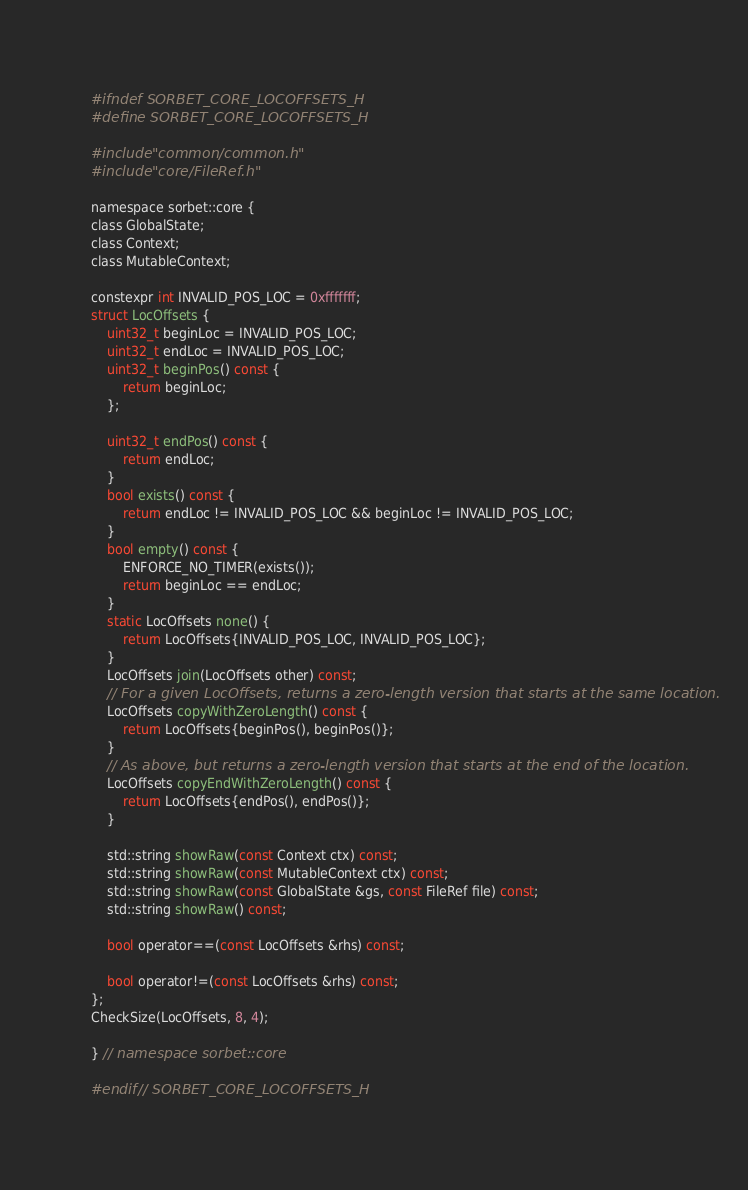<code> <loc_0><loc_0><loc_500><loc_500><_C_>#ifndef SORBET_CORE_LOCOFFSETS_H
#define SORBET_CORE_LOCOFFSETS_H

#include "common/common.h"
#include "core/FileRef.h"

namespace sorbet::core {
class GlobalState;
class Context;
class MutableContext;

constexpr int INVALID_POS_LOC = 0xfffffff;
struct LocOffsets {
    uint32_t beginLoc = INVALID_POS_LOC;
    uint32_t endLoc = INVALID_POS_LOC;
    uint32_t beginPos() const {
        return beginLoc;
    };

    uint32_t endPos() const {
        return endLoc;
    }
    bool exists() const {
        return endLoc != INVALID_POS_LOC && beginLoc != INVALID_POS_LOC;
    }
    bool empty() const {
        ENFORCE_NO_TIMER(exists());
        return beginLoc == endLoc;
    }
    static LocOffsets none() {
        return LocOffsets{INVALID_POS_LOC, INVALID_POS_LOC};
    }
    LocOffsets join(LocOffsets other) const;
    // For a given LocOffsets, returns a zero-length version that starts at the same location.
    LocOffsets copyWithZeroLength() const {
        return LocOffsets{beginPos(), beginPos()};
    }
    // As above, but returns a zero-length version that starts at the end of the location.
    LocOffsets copyEndWithZeroLength() const {
        return LocOffsets{endPos(), endPos()};
    }

    std::string showRaw(const Context ctx) const;
    std::string showRaw(const MutableContext ctx) const;
    std::string showRaw(const GlobalState &gs, const FileRef file) const;
    std::string showRaw() const;

    bool operator==(const LocOffsets &rhs) const;

    bool operator!=(const LocOffsets &rhs) const;
};
CheckSize(LocOffsets, 8, 4);

} // namespace sorbet::core

#endif // SORBET_CORE_LOCOFFSETS_H
</code> 